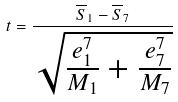<formula> <loc_0><loc_0><loc_500><loc_500>t = \frac { \overline { S } _ { 1 } - \overline { S } _ { 7 } } { \sqrt { \frac { e _ { 1 } ^ { 7 } } { M _ { 1 } } + \frac { e _ { 7 } ^ { 7 } } { M _ { 7 } } } }</formula> 